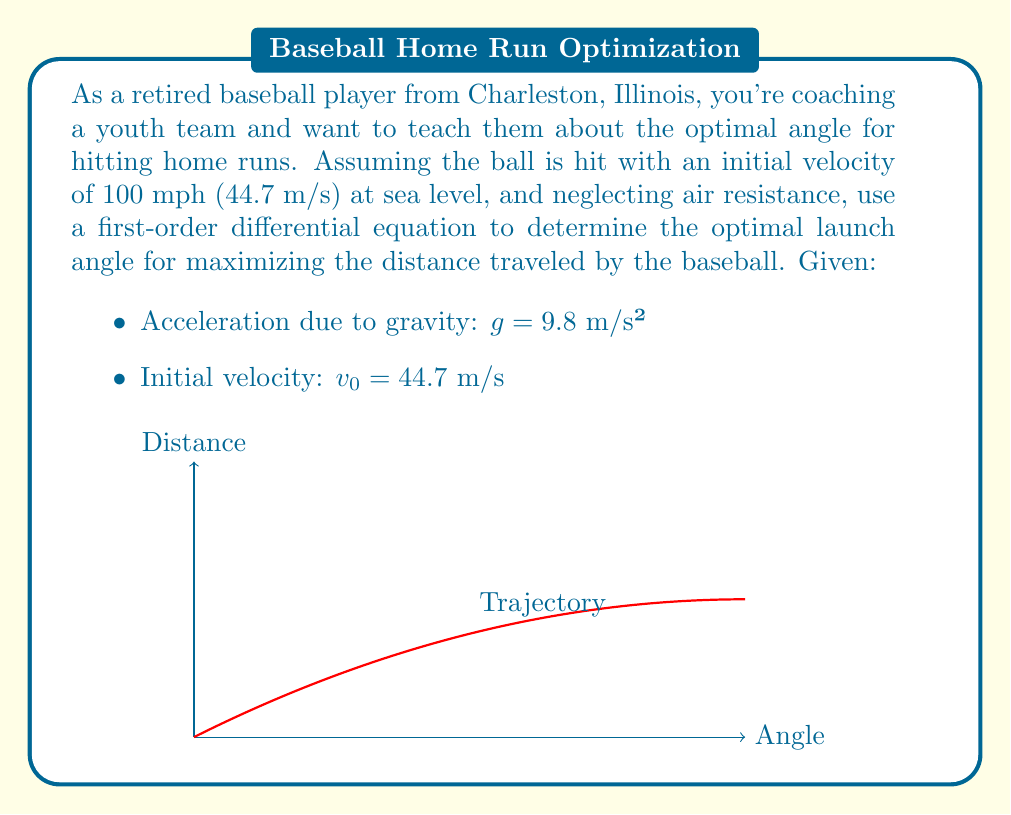What is the answer to this math problem? Let's approach this step-by-step:

1) The motion of the baseball can be described by two first-order differential equations:

   $$\frac{dx}{dt} = v_0 \cos(\theta)$$
   $$\frac{dy}{dt} = v_0 \sin(\theta) - gt$$

   where $x$ is the horizontal distance, $y$ is the vertical distance, $t$ is time, $\theta$ is the launch angle, and $g$ is the acceleration due to gravity.

2) The time of flight can be found when $y = 0$ at the end of the trajectory:

   $$0 = v_0 \sin(\theta)t - \frac{1}{2}gt^2$$

3) Solving this quadratic equation for $t$:

   $$t = \frac{2v_0 \sin(\theta)}{g}$$

4) The horizontal distance traveled is:

   $$x = v_0 \cos(\theta)t = \frac{2v_0^2 \sin(\theta)\cos(\theta)}{g}$$

5) Using the trigonometric identity $\sin(2\theta) = 2\sin(\theta)\cos(\theta)$, we get:

   $$x = \frac{v_0^2 \sin(2\theta)}{g}$$

6) To find the maximum distance, we differentiate with respect to $\theta$ and set it to zero:

   $$\frac{dx}{d\theta} = \frac{v_0^2 \cos(2\theta)}{g} = 0$$

7) This gives us:

   $$\cos(2\theta) = 0$$
   $$2\theta = 90°$$
   $$\theta = 45°$$

8) To confirm this is a maximum, we can check the second derivative is negative at this point.

Therefore, the optimal launch angle for maximum distance is 45°.
Answer: 45° 